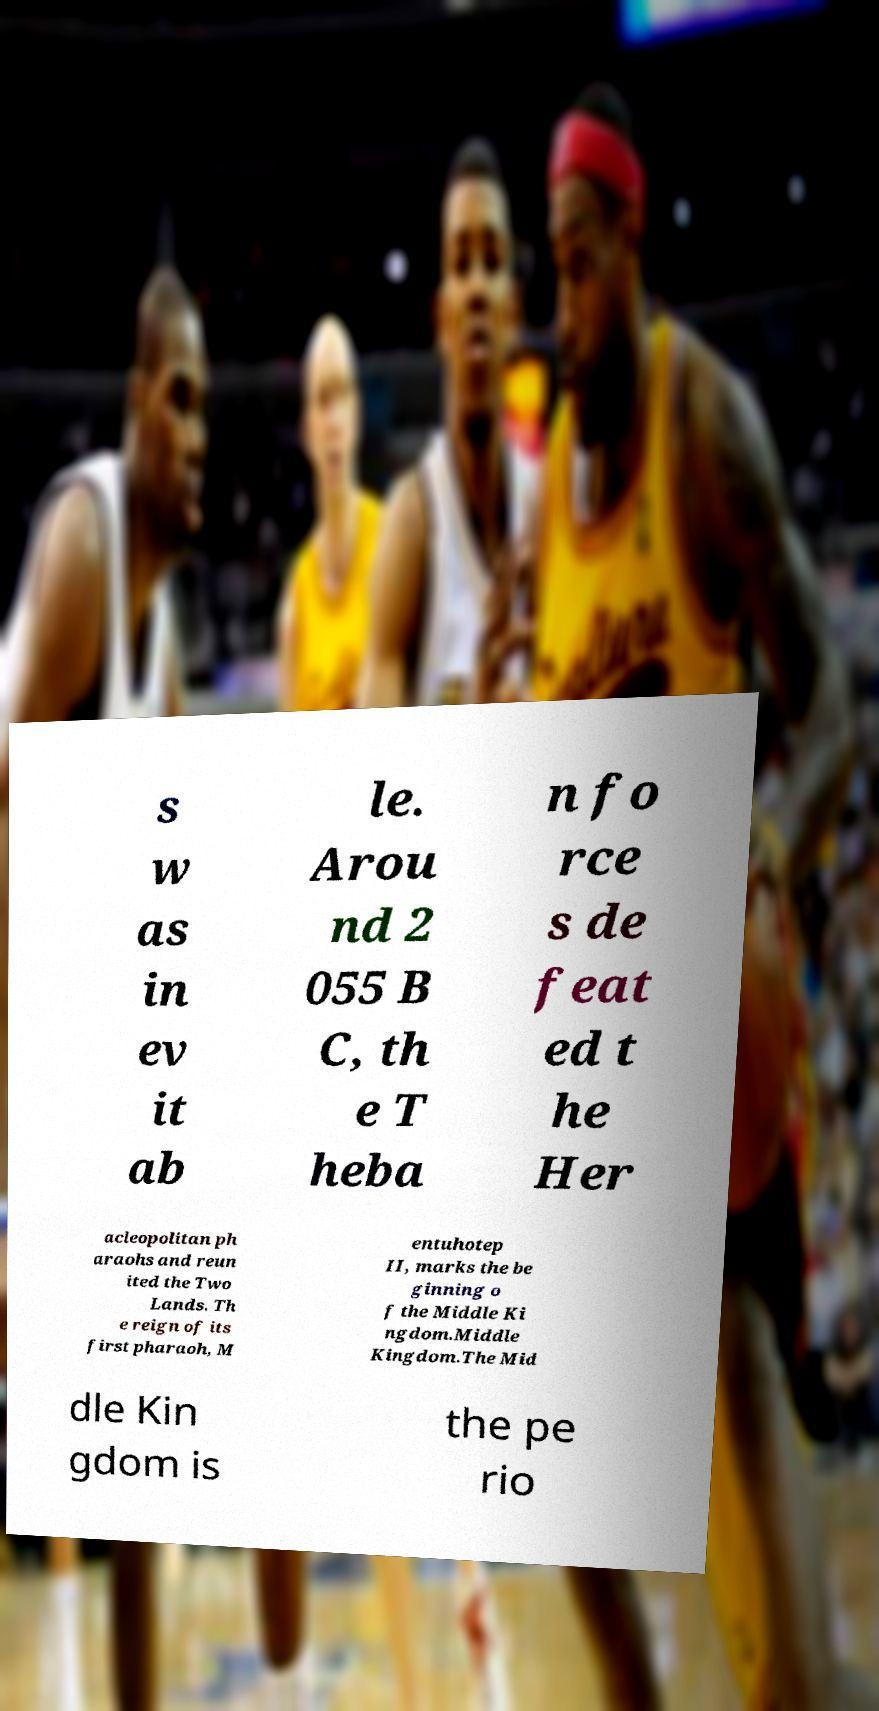Can you accurately transcribe the text from the provided image for me? s w as in ev it ab le. Arou nd 2 055 B C, th e T heba n fo rce s de feat ed t he Her acleopolitan ph araohs and reun ited the Two Lands. Th e reign of its first pharaoh, M entuhotep II, marks the be ginning o f the Middle Ki ngdom.Middle Kingdom.The Mid dle Kin gdom is the pe rio 